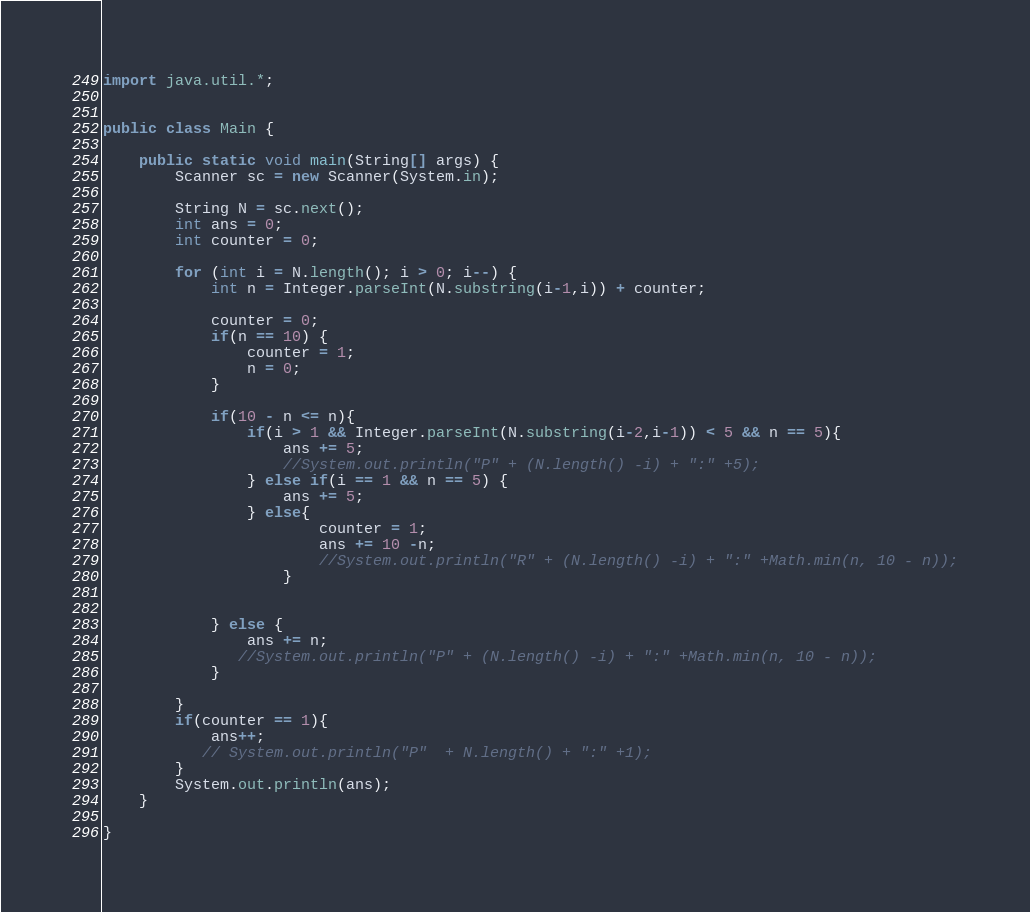Convert code to text. <code><loc_0><loc_0><loc_500><loc_500><_Java_>import java.util.*;


public class Main {

    public static void main(String[] args) {
        Scanner sc = new Scanner(System.in);

        String N = sc.next();
        int ans = 0;
        int counter = 0;

        for (int i = N.length(); i > 0; i--) {
            int n = Integer.parseInt(N.substring(i-1,i)) + counter;

            counter = 0;
            if(n == 10) {
                counter = 1;
                n = 0;
            }

            if(10 - n <= n){
                if(i > 1 && Integer.parseInt(N.substring(i-2,i-1)) < 5 && n == 5){
                    ans += 5;
                    //System.out.println("P" + (N.length() -i) + ":" +5);
                } else if(i == 1 && n == 5) {
                    ans += 5;
                } else{
                        counter = 1;
                        ans += 10 -n;
                        //System.out.println("R" + (N.length() -i) + ":" +Math.min(n, 10 - n));
                    }


            } else {
                ans += n;
               //System.out.println("P" + (N.length() -i) + ":" +Math.min(n, 10 - n));
            }

        }
        if(counter == 1){
            ans++;
           // System.out.println("P"  + N.length() + ":" +1);
        }
        System.out.println(ans);
    }

}






</code> 